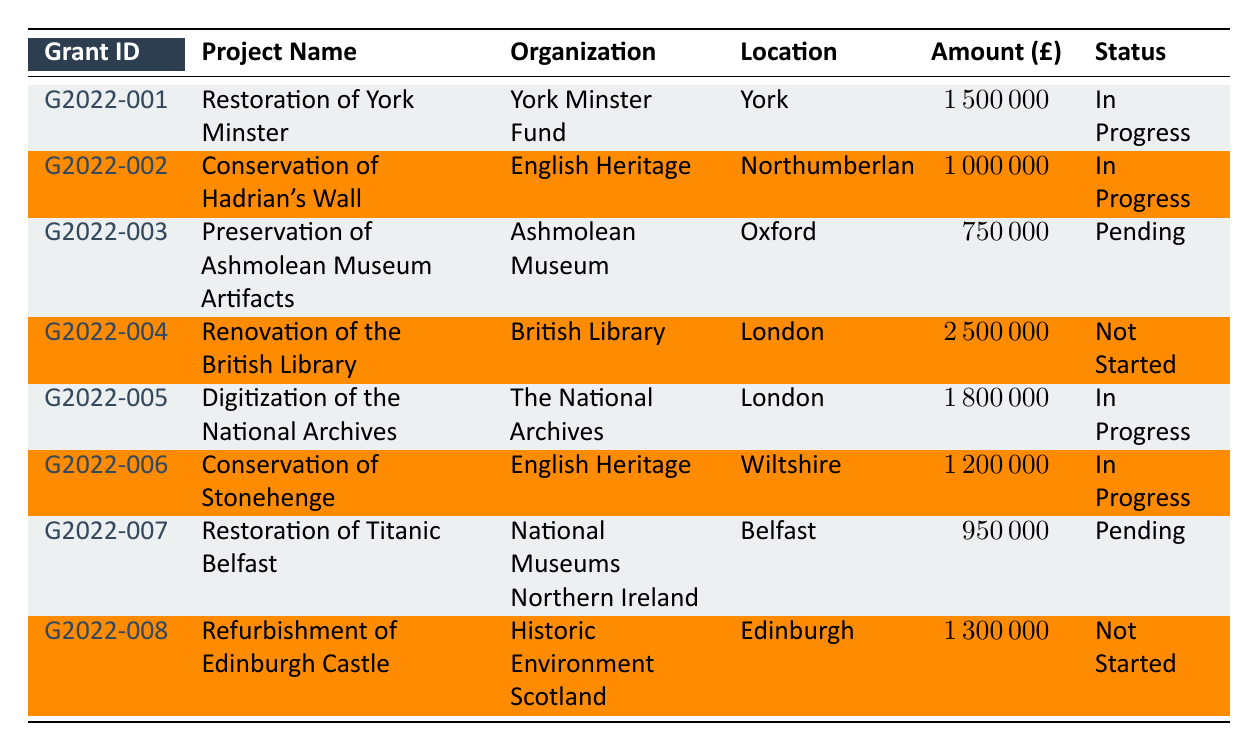What is the total amount allocated for the restoration of York Minster? The table indicates that the amount allocated for the restoration of York Minster is listed under "Amount Allocated," which shows as 1,500,000.
Answer: 1,500,000 Which organization is responsible for the conservation of Hadrian's Wall? Looking at the table, the entry under the "Project Name" for Hadrian's Wall indicates that the responsible organization is English Heritage.
Answer: English Heritage How many projects have a status of "In Progress"? By scanning the "Project Status" column, there are 4 projects that are marked as "In Progress": Restoration of York Minster, Conservation of Hadrian's Wall, Digitization of the National Archives, and Conservation of Stonehenge.
Answer: 4 What is the sum of the amounts allocated to projects that are "Not Started"? The projects listed as "Not Started" are the Renovation of the British Library and the Refurbishment of Edinburgh Castle, with allocated amounts of 2,500,000 and 1,300,000 respectively. Therefore, the sum is (2,500,000 + 1,300,000) = 3,800,000.
Answer: 3,800,000 Is the Ashmolean Museum project currently in progress? Referring to the "Project Status" for the Ashmolean Museum project, it is noted as "Pending," indicating that it is not currently in progress.
Answer: No Which project has the highest amount allocated? By comparing the "Amount Allocated" across all projects, the British Library project has the highest allocation of 2,500,000.
Answer: Renovation of the British Library Are there any projects located in London? The table contains multiple entries for projects in London, including the Renovation of the British Library and the Digitization of the National Archives, confirming that there are projects based in London.
Answer: Yes What is the average amount allocated for all projects? The total amount allocated across all eight projects is (1,500,000 + 1,000,000 + 750,000 + 2,500,000 + 1,800,000 + 1,200,000 + 950,000 + 1,300,000) = 10,000,000. Since there are 8 projects, the average is 10,000,000 / 8 = 1,250,000.
Answer: 1,250,000 How many projects have been allocated funds by the National Heritage Lottery Fund? By checking the "Funding Body" for each project, there are three projects receiving funds from the National Heritage Lottery Fund: the Restoration of York Minster, Preservation of Ashmolean Museum Artifacts, and Conservation of Stonehenge.
Answer: 3 